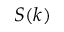Convert formula to latex. <formula><loc_0><loc_0><loc_500><loc_500>S ( k )</formula> 